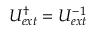<formula> <loc_0><loc_0><loc_500><loc_500>U _ { e x t } ^ { \dagger } = U _ { e x t } ^ { - 1 }</formula> 